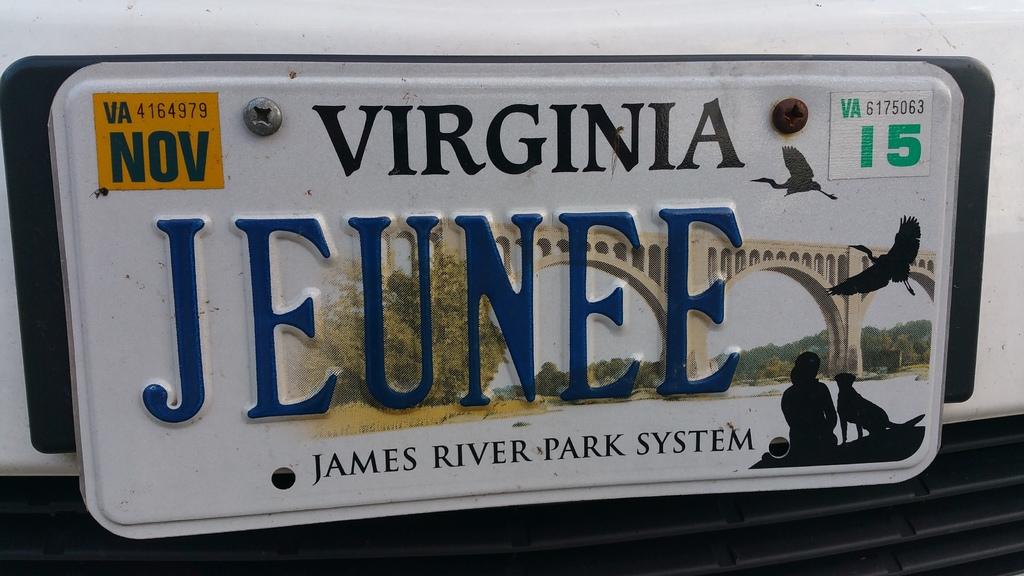What state does this license plate belong to?
Your answer should be compact. Virginia. What month is shown?
Your answer should be very brief. November. 